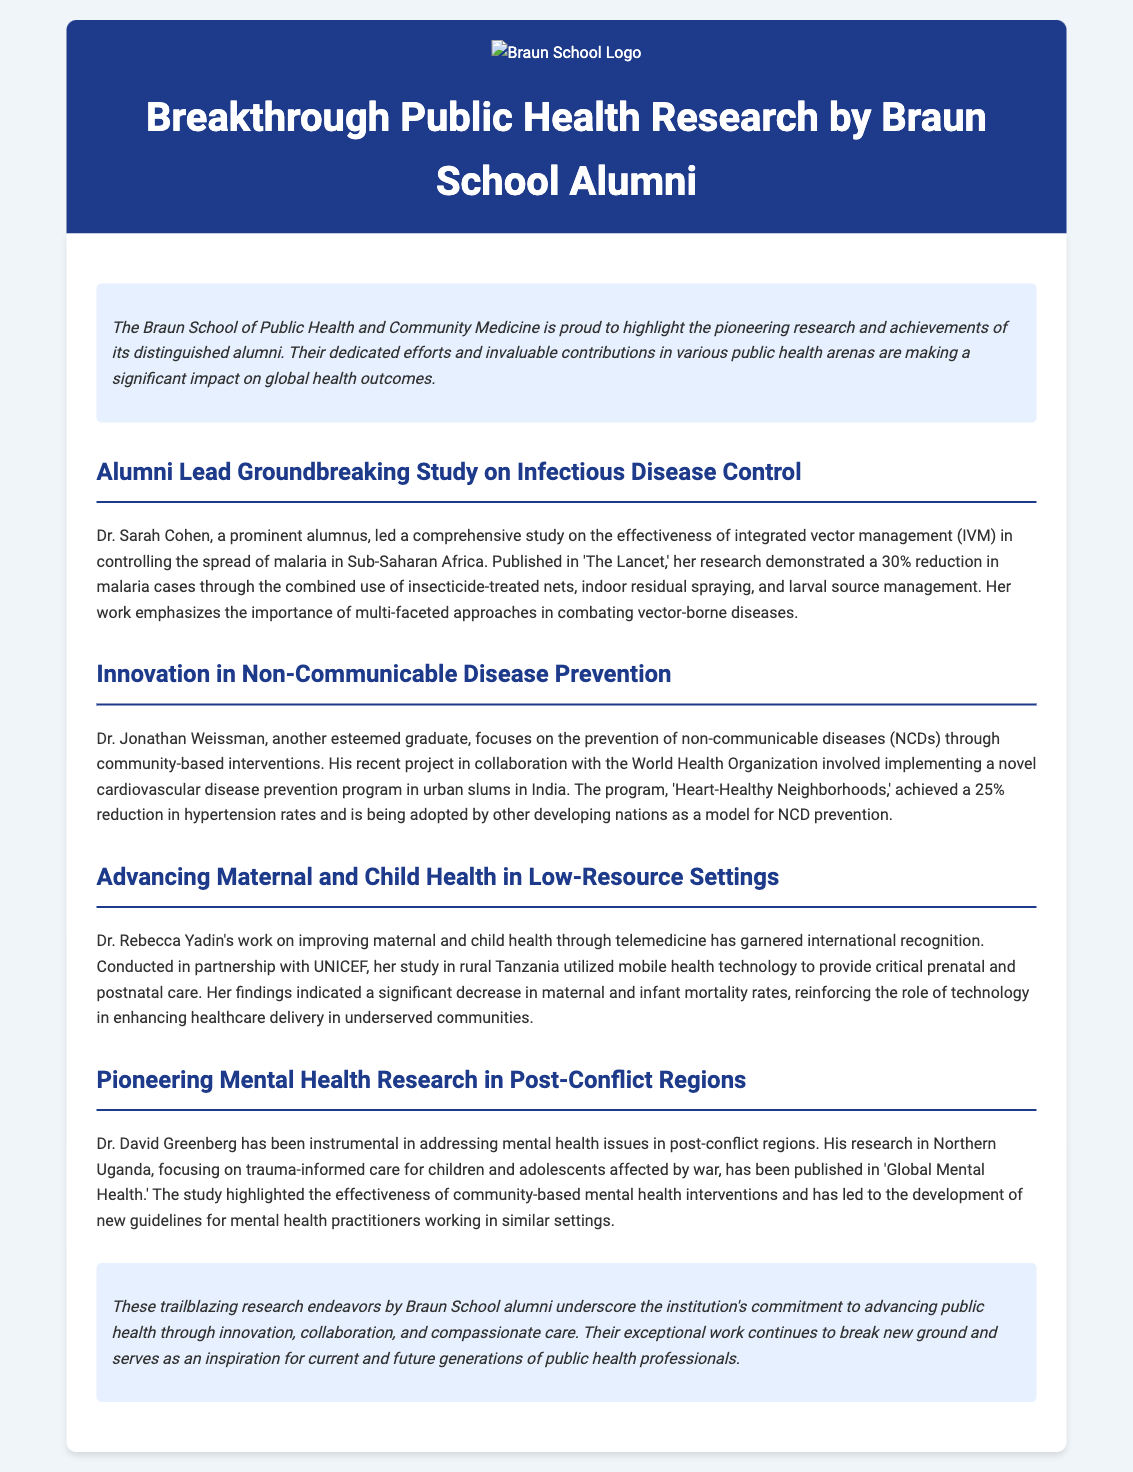what is the title of the press release? The title of the press release is displayed prominently at the top of the document.
Answer: Breakthrough Public Health Research by Braun School Alumni who led the study on infectious disease control? The document specifies the person who led the groundbreaking study on infectious disease control.
Answer: Dr. Sarah Cohen what percentage reduction in malaria cases was reported? The press release states a specific percentage related to malaria case reduction based on Dr. Cohen's research.
Answer: 30% what program did Dr. Weissman implement? The document mentions the name of the cardiovascular disease prevention program established in urban slums in India.
Answer: Heart-Healthy Neighborhoods which organization collaborated in Dr. Yadin's study? The text identifies the organization that worked in partnership with Dr. Yadin on maternal and child health.
Answer: UNICEF what was the focus of Dr. Greenberg's research? The press release describes the main subject of Dr. Greenberg's research in post-conflict regions.
Answer: trauma-informed care how many alumni are highlighted in the document? The document presents several alumni and their contributions, indicating the total number of individuals featured.
Answer: Four what type of health issues does Dr. Greenberg address? The document provides information on the specific health issues targeted by Dr. Greenberg's research.
Answer: mental health what is emphasized as important in combating vector-borne diseases? The text refers to a crucial approach highlighted in Dr. Cohen's research regarding vector-borne diseases.
Answer: multi-faceted approaches 